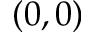Convert formula to latex. <formula><loc_0><loc_0><loc_500><loc_500>( 0 , 0 )</formula> 